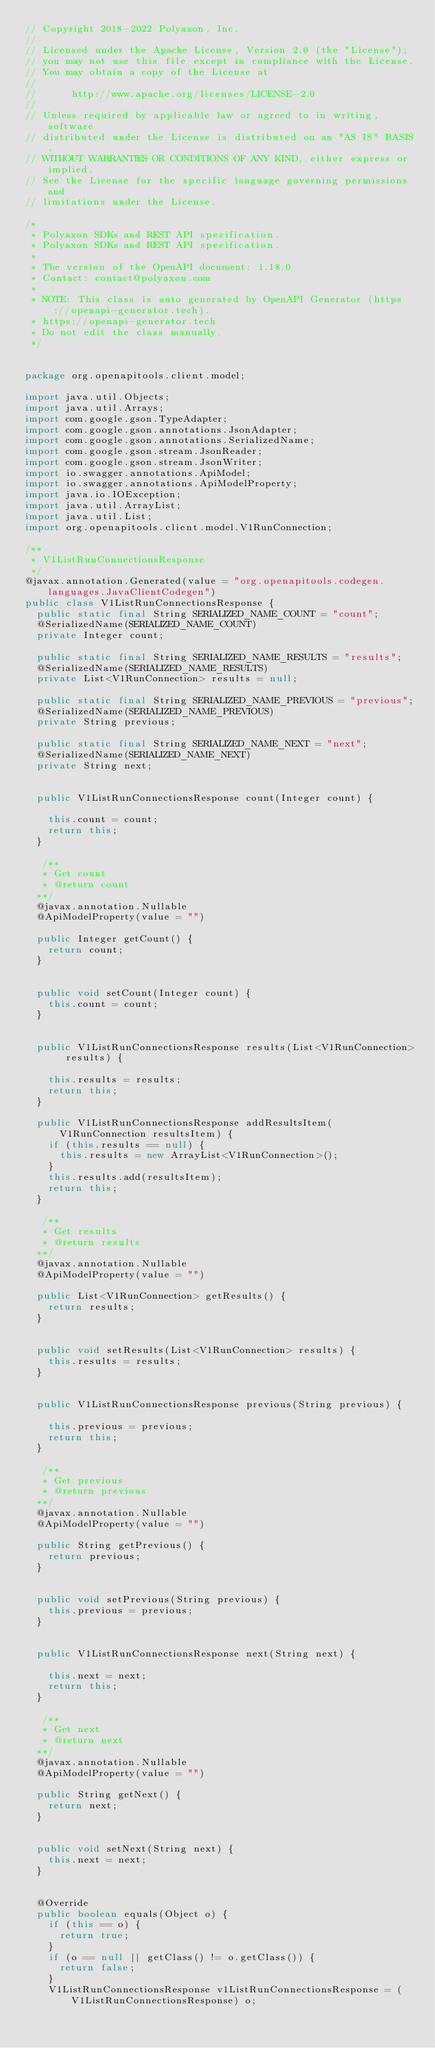Convert code to text. <code><loc_0><loc_0><loc_500><loc_500><_Java_>// Copyright 2018-2022 Polyaxon, Inc.
//
// Licensed under the Apache License, Version 2.0 (the "License");
// you may not use this file except in compliance with the License.
// You may obtain a copy of the License at
//
//      http://www.apache.org/licenses/LICENSE-2.0
//
// Unless required by applicable law or agreed to in writing, software
// distributed under the License is distributed on an "AS IS" BASIS,
// WITHOUT WARRANTIES OR CONDITIONS OF ANY KIND, either express or implied.
// See the License for the specific language governing permissions and
// limitations under the License.

/*
 * Polyaxon SDKs and REST API specification.
 * Polyaxon SDKs and REST API specification.
 *
 * The version of the OpenAPI document: 1.18.0
 * Contact: contact@polyaxon.com
 *
 * NOTE: This class is auto generated by OpenAPI Generator (https://openapi-generator.tech).
 * https://openapi-generator.tech
 * Do not edit the class manually.
 */


package org.openapitools.client.model;

import java.util.Objects;
import java.util.Arrays;
import com.google.gson.TypeAdapter;
import com.google.gson.annotations.JsonAdapter;
import com.google.gson.annotations.SerializedName;
import com.google.gson.stream.JsonReader;
import com.google.gson.stream.JsonWriter;
import io.swagger.annotations.ApiModel;
import io.swagger.annotations.ApiModelProperty;
import java.io.IOException;
import java.util.ArrayList;
import java.util.List;
import org.openapitools.client.model.V1RunConnection;

/**
 * V1ListRunConnectionsResponse
 */
@javax.annotation.Generated(value = "org.openapitools.codegen.languages.JavaClientCodegen")
public class V1ListRunConnectionsResponse {
  public static final String SERIALIZED_NAME_COUNT = "count";
  @SerializedName(SERIALIZED_NAME_COUNT)
  private Integer count;

  public static final String SERIALIZED_NAME_RESULTS = "results";
  @SerializedName(SERIALIZED_NAME_RESULTS)
  private List<V1RunConnection> results = null;

  public static final String SERIALIZED_NAME_PREVIOUS = "previous";
  @SerializedName(SERIALIZED_NAME_PREVIOUS)
  private String previous;

  public static final String SERIALIZED_NAME_NEXT = "next";
  @SerializedName(SERIALIZED_NAME_NEXT)
  private String next;


  public V1ListRunConnectionsResponse count(Integer count) {
    
    this.count = count;
    return this;
  }

   /**
   * Get count
   * @return count
  **/
  @javax.annotation.Nullable
  @ApiModelProperty(value = "")

  public Integer getCount() {
    return count;
  }


  public void setCount(Integer count) {
    this.count = count;
  }


  public V1ListRunConnectionsResponse results(List<V1RunConnection> results) {
    
    this.results = results;
    return this;
  }

  public V1ListRunConnectionsResponse addResultsItem(V1RunConnection resultsItem) {
    if (this.results == null) {
      this.results = new ArrayList<V1RunConnection>();
    }
    this.results.add(resultsItem);
    return this;
  }

   /**
   * Get results
   * @return results
  **/
  @javax.annotation.Nullable
  @ApiModelProperty(value = "")

  public List<V1RunConnection> getResults() {
    return results;
  }


  public void setResults(List<V1RunConnection> results) {
    this.results = results;
  }


  public V1ListRunConnectionsResponse previous(String previous) {
    
    this.previous = previous;
    return this;
  }

   /**
   * Get previous
   * @return previous
  **/
  @javax.annotation.Nullable
  @ApiModelProperty(value = "")

  public String getPrevious() {
    return previous;
  }


  public void setPrevious(String previous) {
    this.previous = previous;
  }


  public V1ListRunConnectionsResponse next(String next) {
    
    this.next = next;
    return this;
  }

   /**
   * Get next
   * @return next
  **/
  @javax.annotation.Nullable
  @ApiModelProperty(value = "")

  public String getNext() {
    return next;
  }


  public void setNext(String next) {
    this.next = next;
  }


  @Override
  public boolean equals(Object o) {
    if (this == o) {
      return true;
    }
    if (o == null || getClass() != o.getClass()) {
      return false;
    }
    V1ListRunConnectionsResponse v1ListRunConnectionsResponse = (V1ListRunConnectionsResponse) o;</code> 